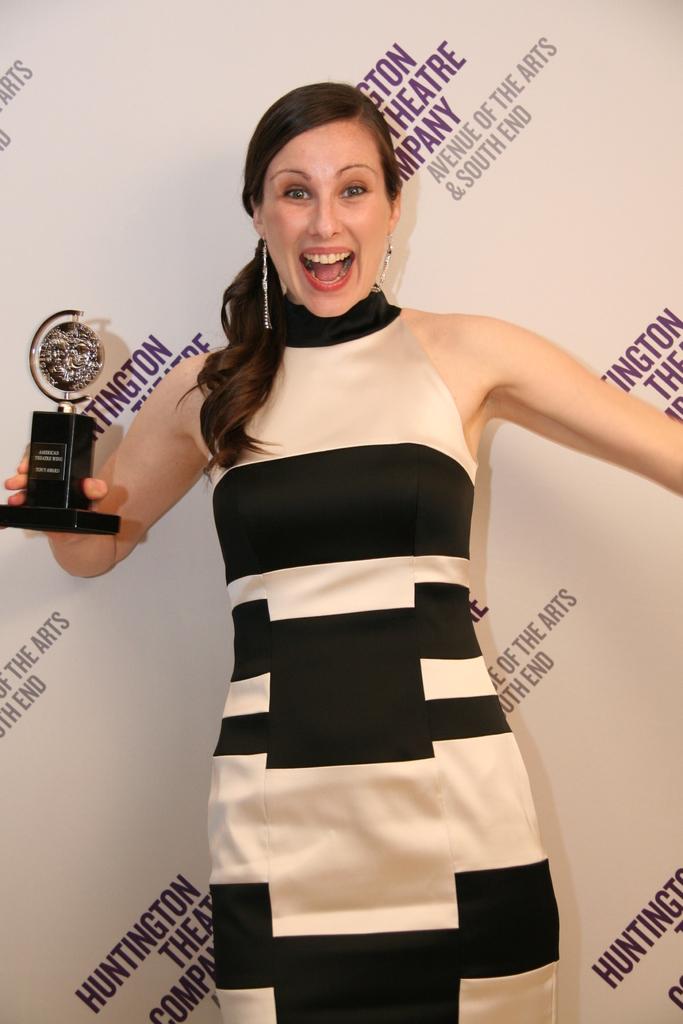What is the name of the theatre company?
Provide a short and direct response. Huntington. 